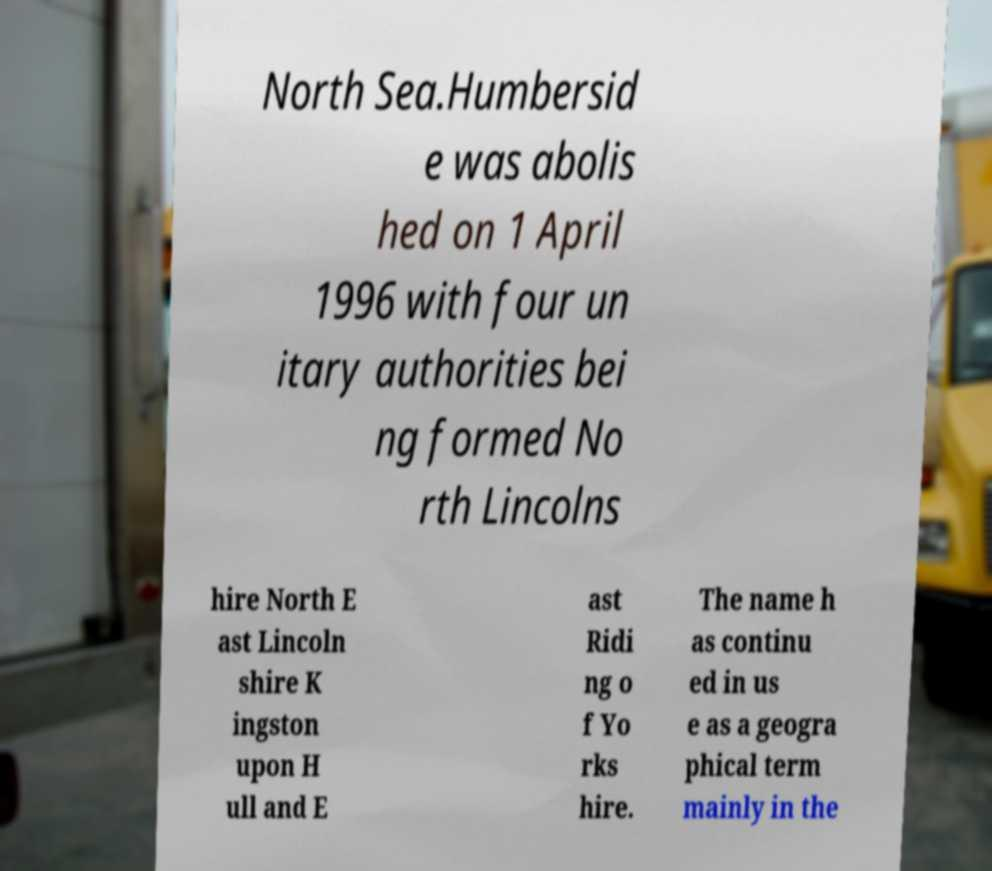I need the written content from this picture converted into text. Can you do that? North Sea.Humbersid e was abolis hed on 1 April 1996 with four un itary authorities bei ng formed No rth Lincolns hire North E ast Lincoln shire K ingston upon H ull and E ast Ridi ng o f Yo rks hire. The name h as continu ed in us e as a geogra phical term mainly in the 